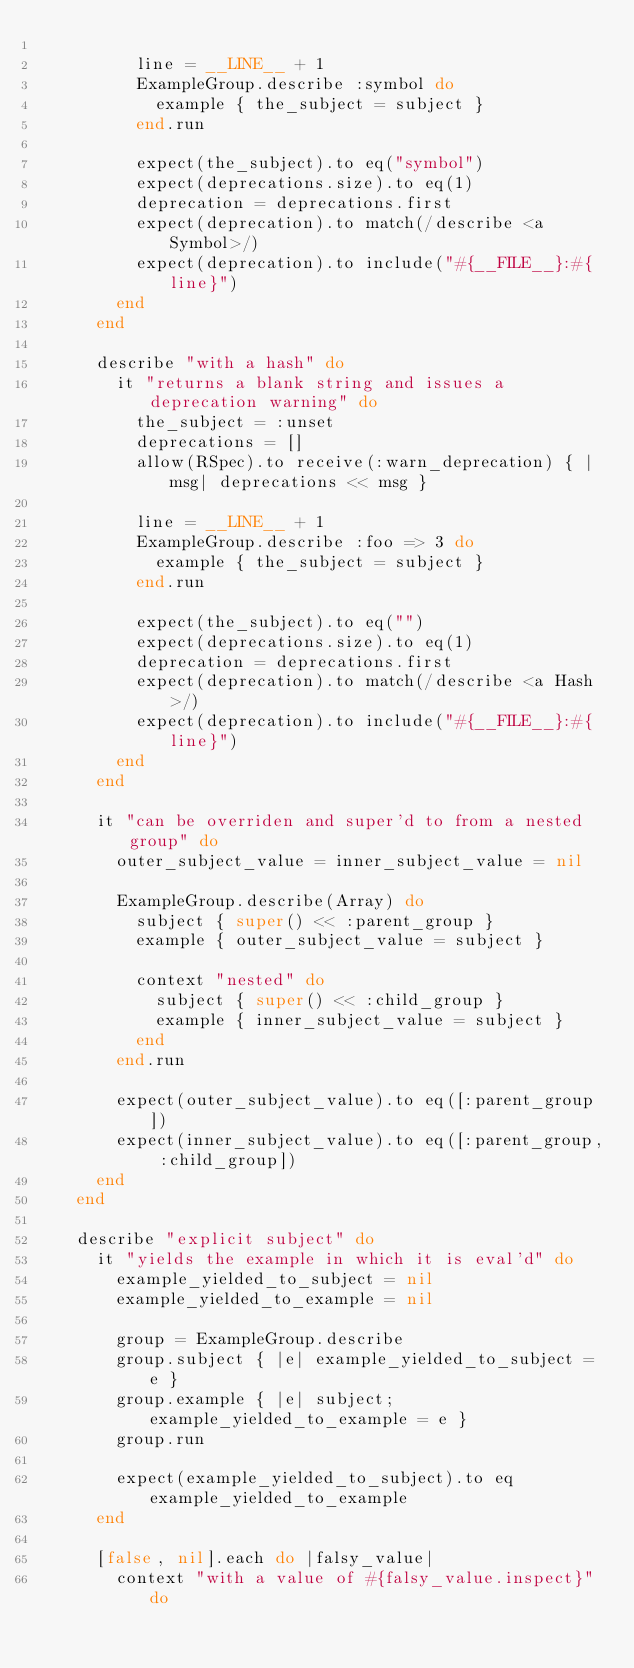<code> <loc_0><loc_0><loc_500><loc_500><_Ruby_>
          line = __LINE__ + 1
          ExampleGroup.describe :symbol do
            example { the_subject = subject }
          end.run

          expect(the_subject).to eq("symbol")
          expect(deprecations.size).to eq(1)
          deprecation = deprecations.first
          expect(deprecation).to match(/describe <a Symbol>/)
          expect(deprecation).to include("#{__FILE__}:#{line}")
        end
      end

      describe "with a hash" do
        it "returns a blank string and issues a deprecation warning" do
          the_subject = :unset
          deprecations = []
          allow(RSpec).to receive(:warn_deprecation) { |msg| deprecations << msg }

          line = __LINE__ + 1
          ExampleGroup.describe :foo => 3 do
            example { the_subject = subject }
          end.run

          expect(the_subject).to eq("")
          expect(deprecations.size).to eq(1)
          deprecation = deprecations.first
          expect(deprecation).to match(/describe <a Hash>/)
          expect(deprecation).to include("#{__FILE__}:#{line}")
        end
      end

      it "can be overriden and super'd to from a nested group" do
        outer_subject_value = inner_subject_value = nil

        ExampleGroup.describe(Array) do
          subject { super() << :parent_group }
          example { outer_subject_value = subject }

          context "nested" do
            subject { super() << :child_group }
            example { inner_subject_value = subject }
          end
        end.run

        expect(outer_subject_value).to eq([:parent_group])
        expect(inner_subject_value).to eq([:parent_group, :child_group])
      end
    end

    describe "explicit subject" do
      it "yields the example in which it is eval'd" do
        example_yielded_to_subject = nil
        example_yielded_to_example = nil

        group = ExampleGroup.describe
        group.subject { |e| example_yielded_to_subject = e }
        group.example { |e| subject; example_yielded_to_example = e }
        group.run

        expect(example_yielded_to_subject).to eq example_yielded_to_example
      end

      [false, nil].each do |falsy_value|
        context "with a value of #{falsy_value.inspect}" do</code> 